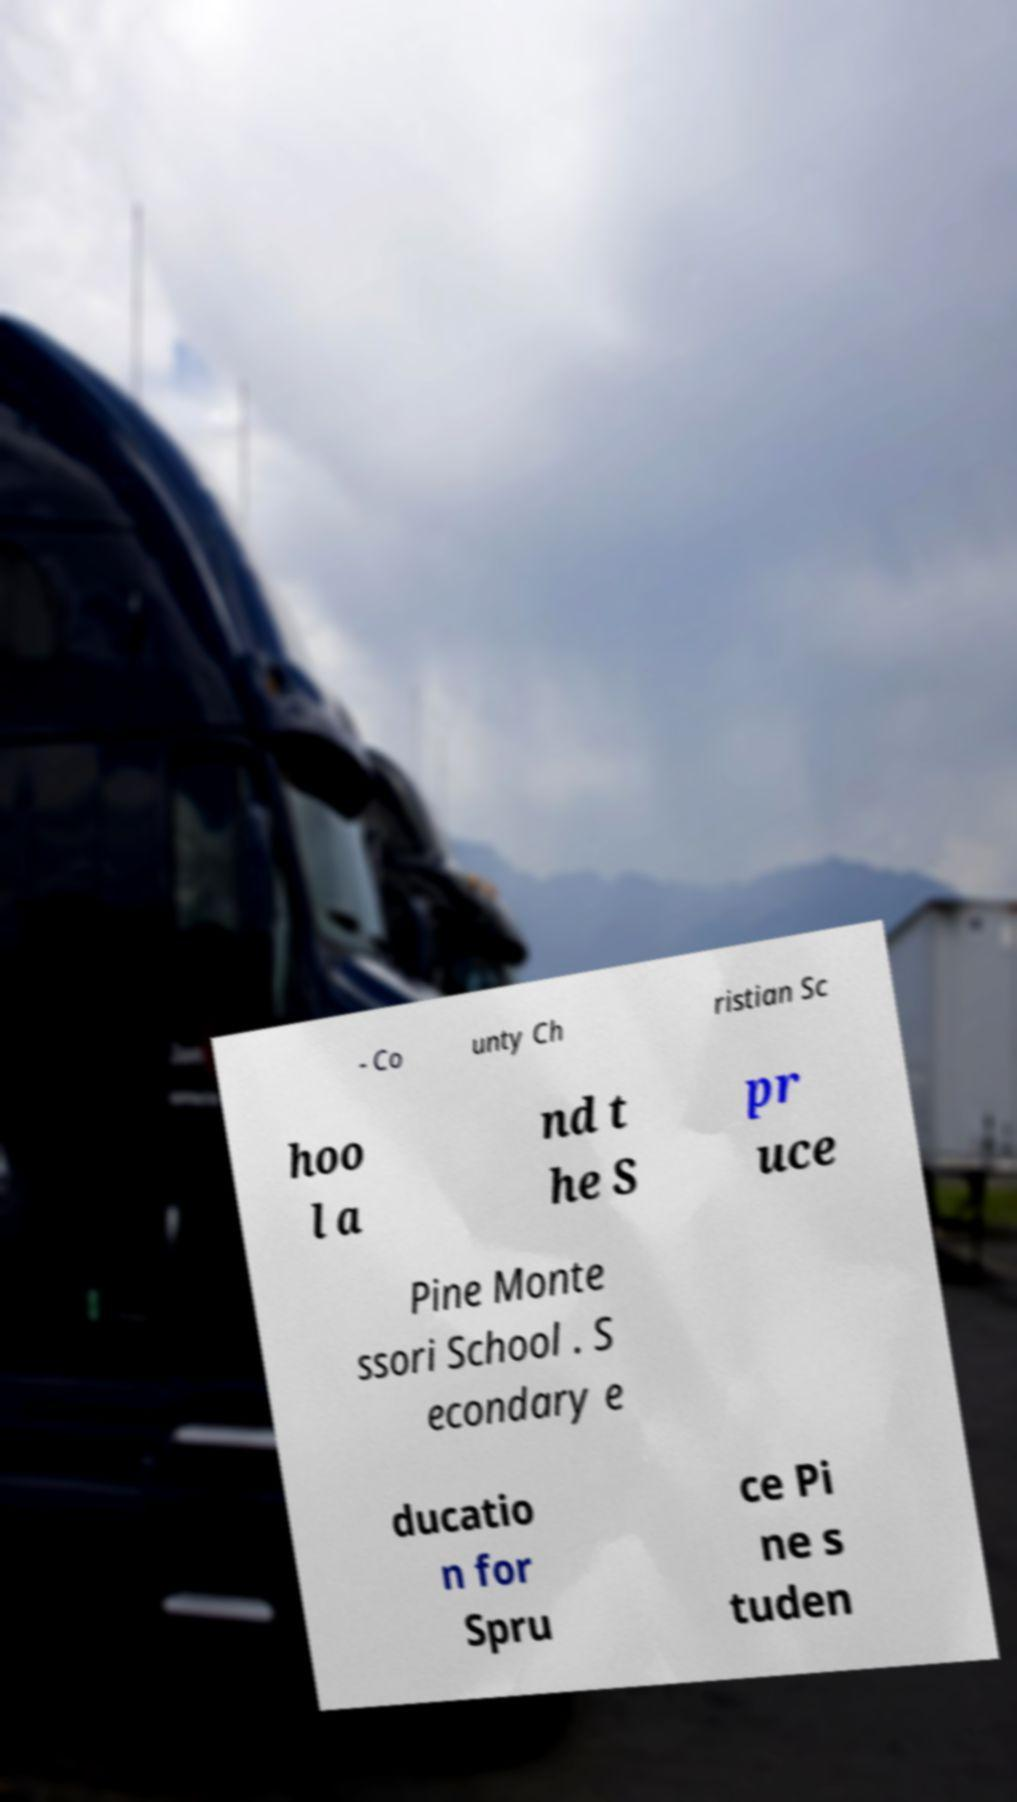Can you read and provide the text displayed in the image?This photo seems to have some interesting text. Can you extract and type it out for me? - Co unty Ch ristian Sc hoo l a nd t he S pr uce Pine Monte ssori School . S econdary e ducatio n for Spru ce Pi ne s tuden 